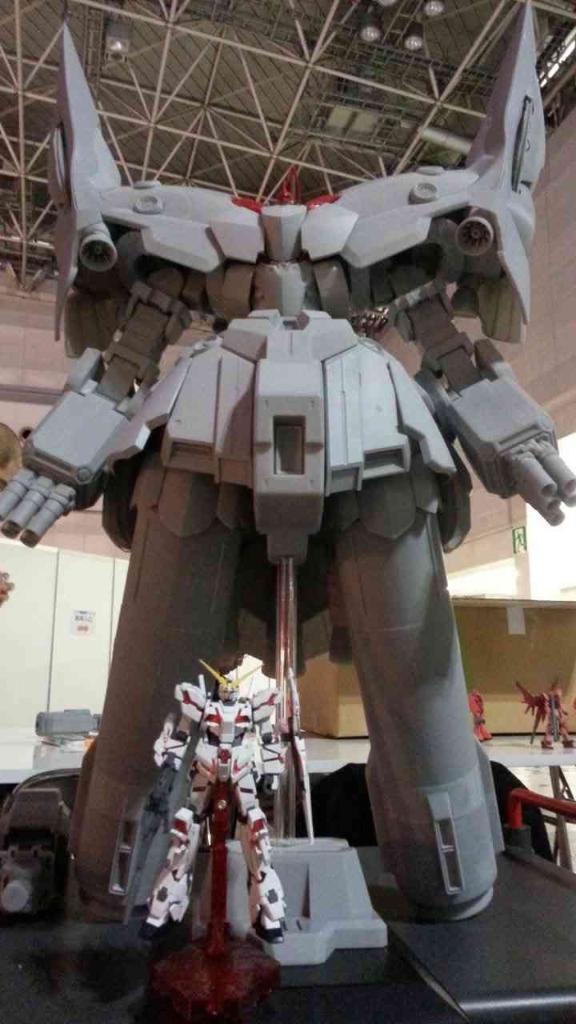How would you summarize this image in a sentence or two? In this image, I can see the transformer robots of different sizes. This looks like a table. I think this is the board. Here is the roof with the lights and iron poles. 